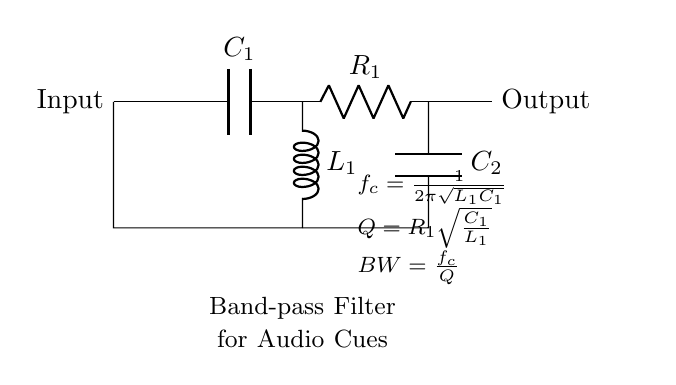What type of filter is represented in this circuit? The circuit diagram is labeled as a "Band-pass Filter," which indicates it allows signals within a certain frequency range to pass while attenuating frequencies outside that range.
Answer: Band-pass filter What are the components used in this filter circuit? The circuit consists of two capacitors (C1, C2), one inductor (L1), and one resistor (R1). Each component is crucial for establishing the filter characteristics.
Answer: Capacitor, inductor, resistor Which component determines the cutoff frequency? The cutoff frequency is determined by the inductor (L1) and the capacitor (C1) based on the formula given: \( f_c = \frac{1}{2\pi\sqrt{L_1C_1}} \), indicating that both components directly influence the cutoff frequency.
Answer: L1 and C1 What is the formula for calculating the quality factor (Q) of this filter? The quality factor (Q) for this filter is calculated using the formula \( Q = R_1\sqrt{\frac{C_1}{L_1}} \), which shows how the resistor influences the sharpness of the filter's passband depending on the values of C1 and L1.
Answer: R1 sqrt(C1/L1) How does increasing the resistance (R1) affect the bandwidth (BW) of the filter? According to the bandwidth formula \( BW = \frac{f_c}{Q} \), increasing R1 will lower the quality factor Q, causing the bandwidth to widen. This means a wider range of frequencies will be allowed through, which may reduce the selectivity of the filter.
Answer: Decreases selectivity What happens to the filter's response if the inductor (L1) value is decreased? Decreasing the value of L1 will increase the cutoff frequency \( f_c \) according to the formula \( f_c = \frac{1}{2\pi\sqrt{L_1C_1}} \), which results in allowing higher frequencies to pass through the filter while attenuating lower frequencies more effectively.
Answer: Increases cutoff frequency 